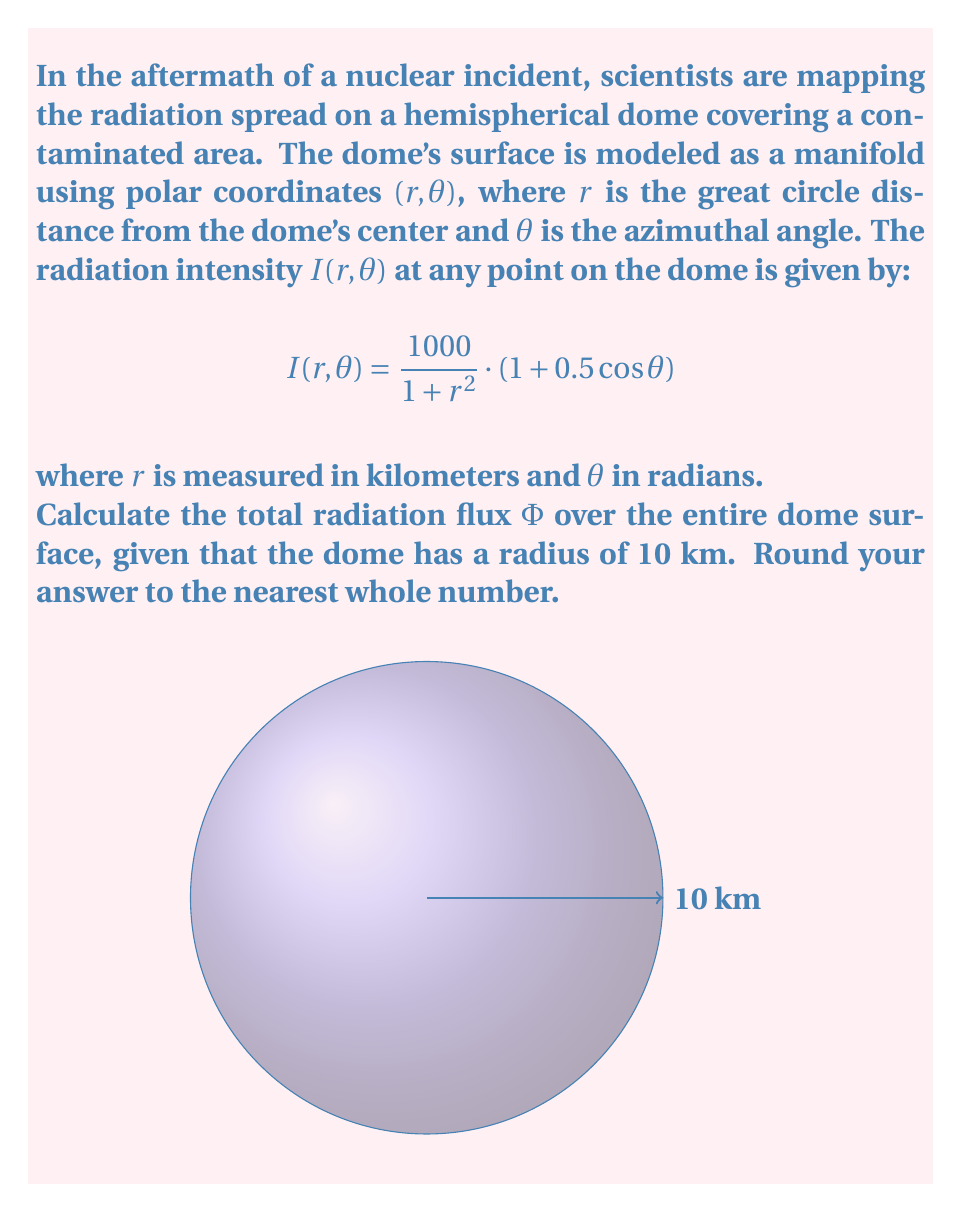Can you answer this question? To solve this problem, we need to integrate the radiation intensity over the entire surface of the hemispherical dome. Let's approach this step-by-step:

1) The flux $\Phi$ is given by the surface integral:

   $$\Phi = \int\int_S I(r,\theta) \, dS$$

2) On a sphere, the surface element $dS$ in polar coordinates is:

   $$dS = R \sin(\frac{r}{R}) \, d\theta \, dr$$

   where $R$ is the radius of the sphere (in this case, 10 km).

3) Substituting the given function and the surface element:

   $$\Phi = \int_0^{2\pi} \int_0^{10} \frac{1000}{1 + r^2} \cdot (1 + 0.5 \cos \theta) \cdot 10 \sin(\frac{r}{10}) \, dr \, d\theta$$

4) We can separate the integrals:

   $$\Phi = 10000 \int_0^{2\pi} (1 + 0.5 \cos \theta) \, d\theta \cdot \int_0^{10} \frac{\sin(\frac{r}{10})}{1 + r^2} \, dr$$

5) Solving the $\theta$ integral:

   $$\int_0^{2\pi} (1 + 0.5 \cos \theta) \, d\theta = [(\theta + 0.5 \sin \theta)]_0^{2\pi} = 2\pi$$

6) The remaining integral doesn't have a simple analytical solution. We need to use numerical integration methods:

   $$\int_0^{10} \frac{\sin(\frac{r}{10})}{1 + r^2} \, dr \approx 0.7618$$

   (This value can be obtained using computational tools or numerical integration methods)

7) Multiplying the results:

   $$\Phi \approx 10000 \cdot 2\pi \cdot 0.7618 \approx 47866.9$$

8) Rounding to the nearest whole number:

   $$\Phi \approx 47867$$
Answer: 47867 